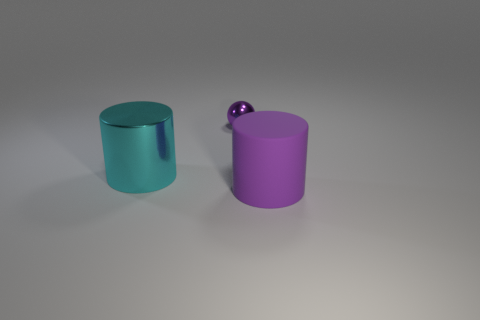Are these objects casting shadows, and if so, what can we infer about the light source in this scene? Yes, both objects are casting shadows. The shadows extend to the right of the objects, which suggests that the light source is to the left, possibly slightly above the horizon of the objects given the angle and length of the shadows. 